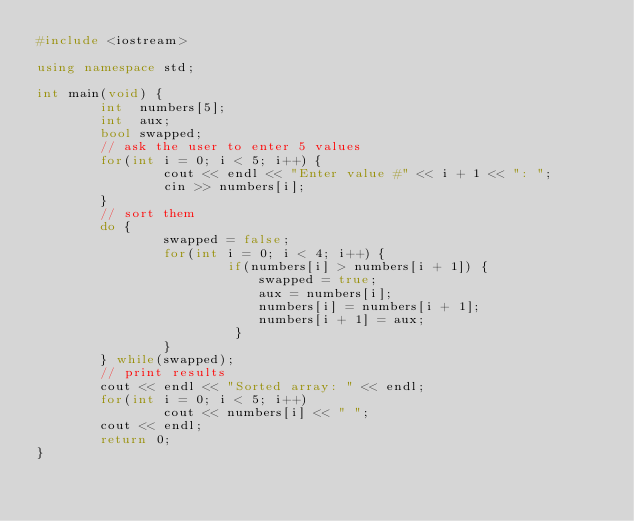Convert code to text. <code><loc_0><loc_0><loc_500><loc_500><_C++_>#include <iostream>
 
using namespace std;

int main(void) {
        int  numbers[5];
        int  aux;
        bool swapped;
        // ask the user to enter 5 values 
        for(int i = 0; i < 5; i++) {
                cout << endl << "Enter value #" << i + 1 << ": ";
                cin >> numbers[i];
        }
        // sort them 
        do {
                swapped = false;
                for(int i = 0; i < 4; i++) {
                        if(numbers[i] > numbers[i + 1]) {
                            swapped = true;
                            aux = numbers[i];
                            numbers[i] = numbers[i + 1];
                            numbers[i + 1] = aux;
                         }
                }
        } while(swapped);
        // print results 
        cout << endl << "Sorted array: " << endl;
        for(int i = 0; i < 5; i++)
                cout << numbers[i] << " ";
        cout << endl;
        return 0;
}
</code> 